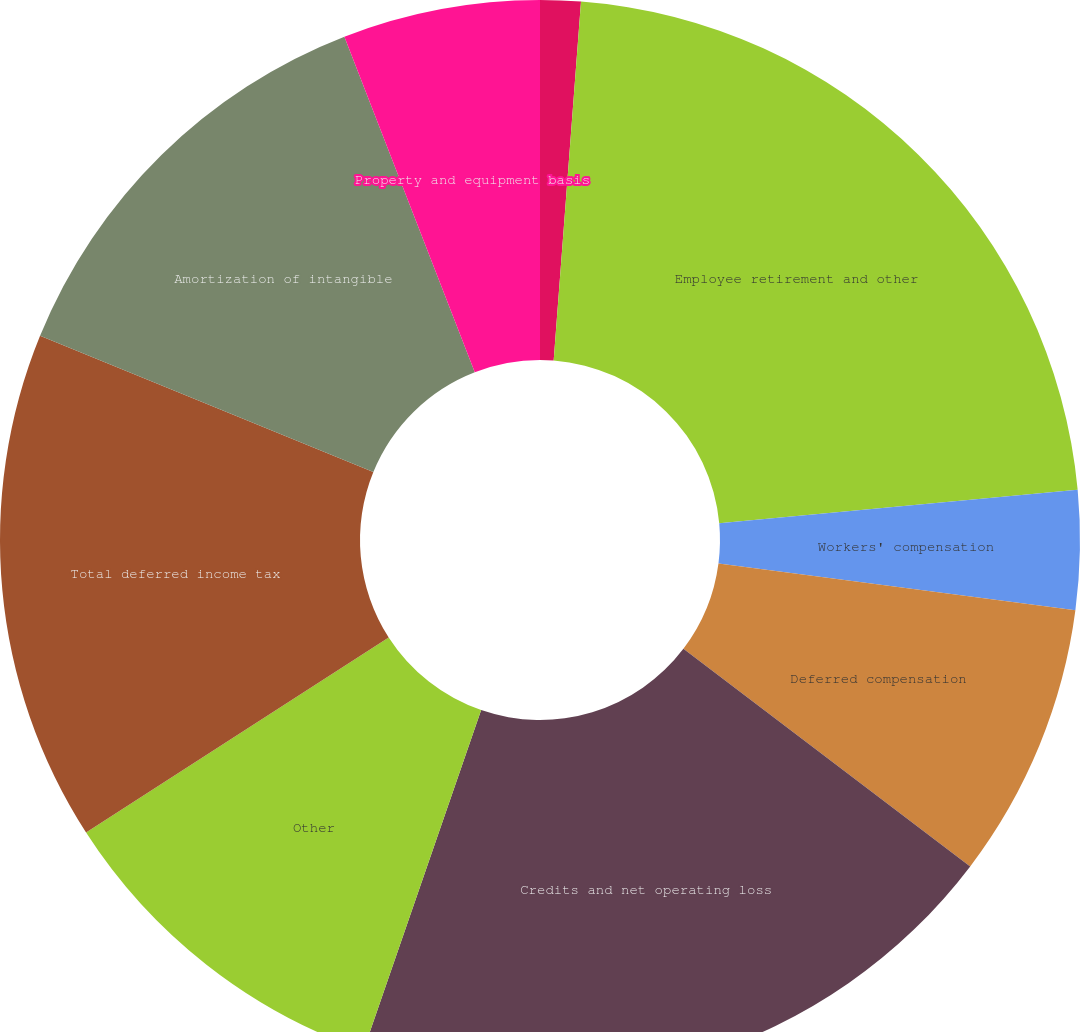Convert chart to OTSL. <chart><loc_0><loc_0><loc_500><loc_500><pie_chart><fcel>Provision for bad debts<fcel>Employee retirement and other<fcel>Workers' compensation<fcel>Deferred compensation<fcel>Credits and net operating loss<fcel>Other<fcel>Total deferred income tax<fcel>Amortization of intangible<fcel>Property and equipment basis<nl><fcel>1.21%<fcel>22.31%<fcel>3.56%<fcel>8.25%<fcel>19.97%<fcel>10.59%<fcel>15.28%<fcel>12.93%<fcel>5.9%<nl></chart> 